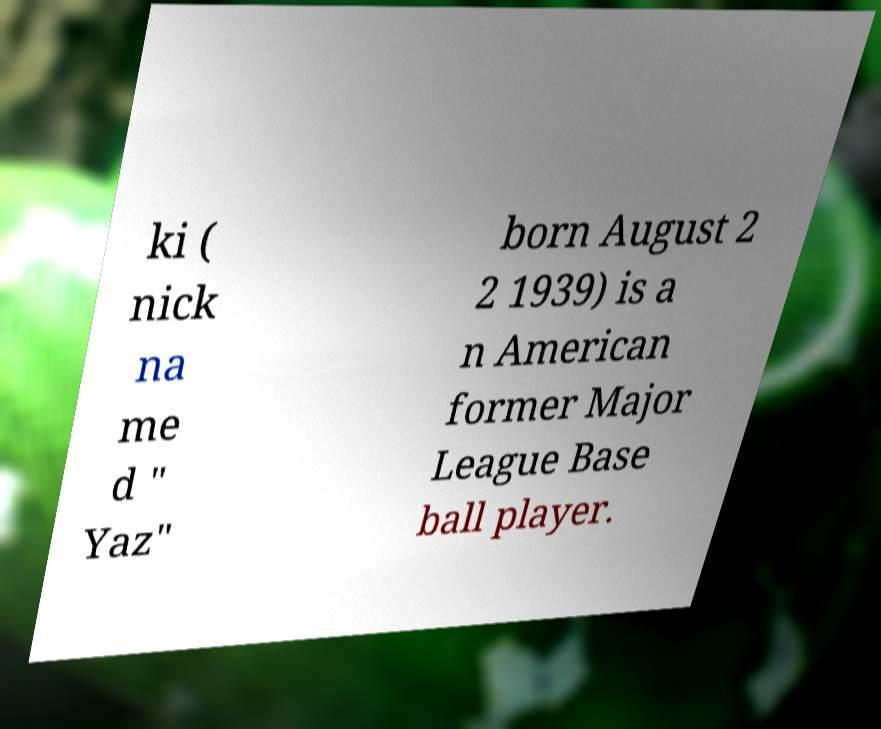Please read and relay the text visible in this image. What does it say? ki ( nick na me d " Yaz" born August 2 2 1939) is a n American former Major League Base ball player. 